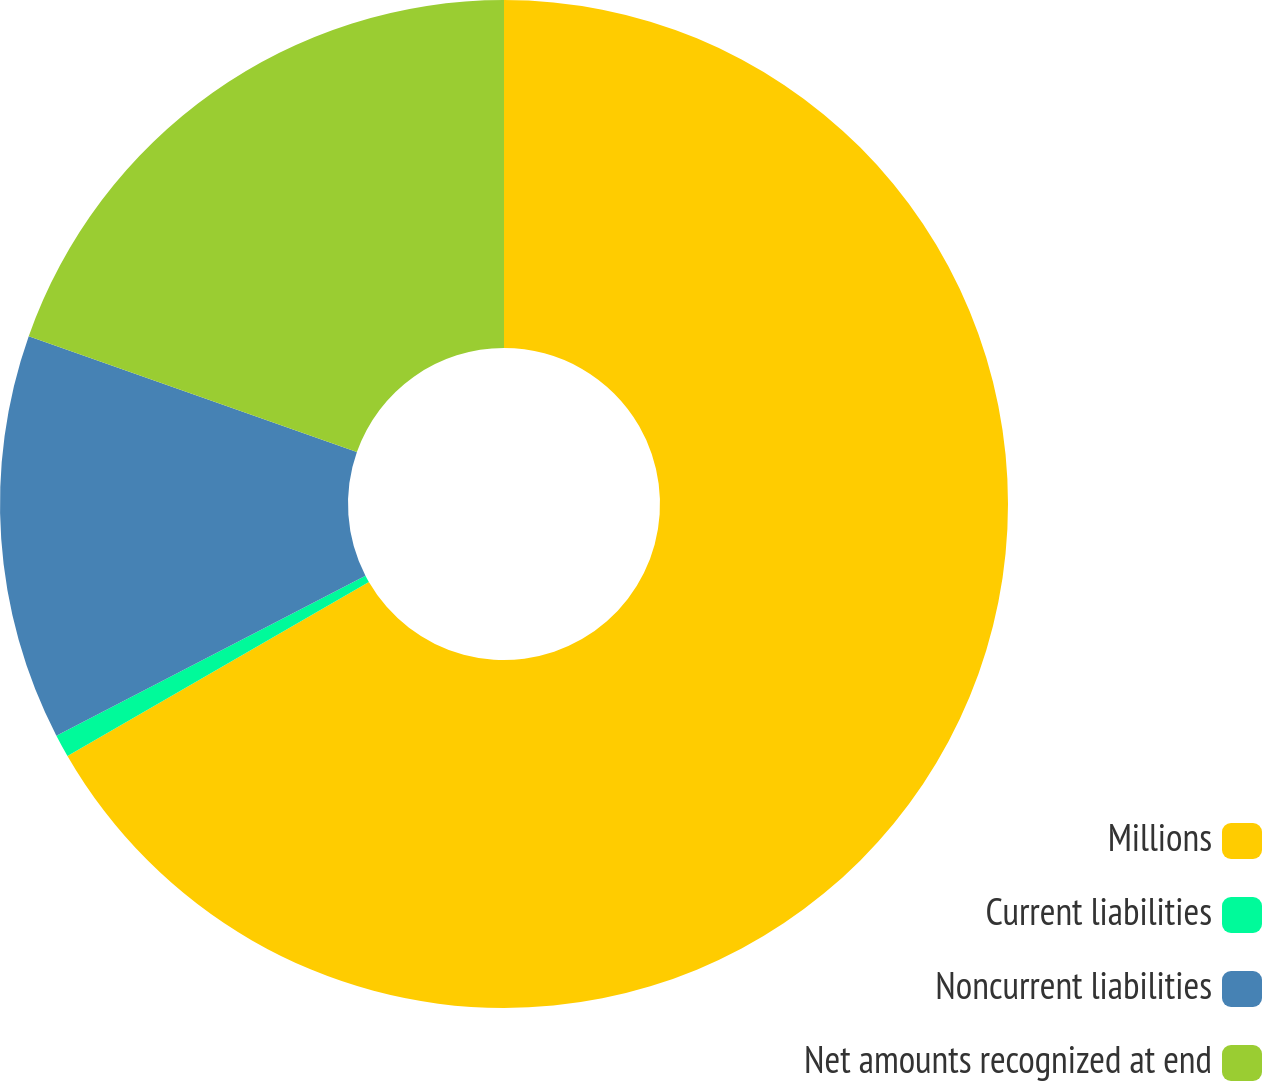Convert chart. <chart><loc_0><loc_0><loc_500><loc_500><pie_chart><fcel>Millions<fcel>Current liabilities<fcel>Noncurrent liabilities<fcel>Net amounts recognized at end<nl><fcel>66.67%<fcel>0.73%<fcel>13.0%<fcel>19.6%<nl></chart> 